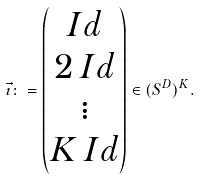Convert formula to latex. <formula><loc_0><loc_0><loc_500><loc_500>\vec { \imath } \colon = \begin{pmatrix} I d \\ 2 \, I d \\ \vdots \\ K \, I d \end{pmatrix} \in ( S ^ { D } ) ^ { K } .</formula> 